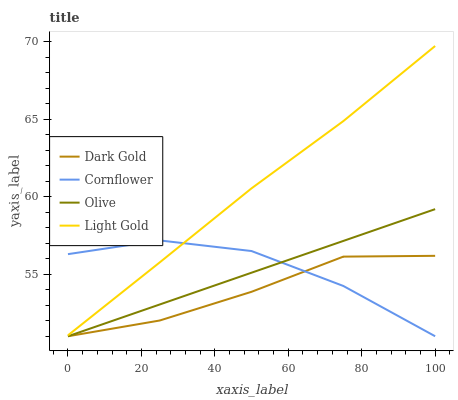Does Dark Gold have the minimum area under the curve?
Answer yes or no. Yes. Does Light Gold have the maximum area under the curve?
Answer yes or no. Yes. Does Cornflower have the minimum area under the curve?
Answer yes or no. No. Does Cornflower have the maximum area under the curve?
Answer yes or no. No. Is Olive the smoothest?
Answer yes or no. Yes. Is Cornflower the roughest?
Answer yes or no. Yes. Is Light Gold the smoothest?
Answer yes or no. No. Is Light Gold the roughest?
Answer yes or no. No. Does Olive have the lowest value?
Answer yes or no. Yes. Does Light Gold have the lowest value?
Answer yes or no. No. Does Light Gold have the highest value?
Answer yes or no. Yes. Does Cornflower have the highest value?
Answer yes or no. No. Is Olive less than Light Gold?
Answer yes or no. Yes. Is Light Gold greater than Olive?
Answer yes or no. Yes. Does Dark Gold intersect Cornflower?
Answer yes or no. Yes. Is Dark Gold less than Cornflower?
Answer yes or no. No. Is Dark Gold greater than Cornflower?
Answer yes or no. No. Does Olive intersect Light Gold?
Answer yes or no. No. 